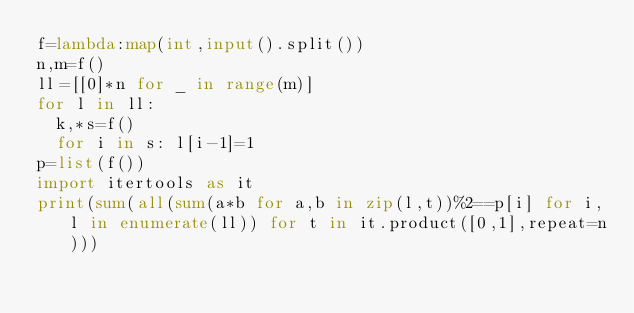<code> <loc_0><loc_0><loc_500><loc_500><_Python_>f=lambda:map(int,input().split())
n,m=f()
ll=[[0]*n for _ in range(m)]
for l in ll:
  k,*s=f()
  for i in s: l[i-1]=1
p=list(f())
import itertools as it
print(sum(all(sum(a*b for a,b in zip(l,t))%2==p[i] for i,l in enumerate(ll)) for t in it.product([0,1],repeat=n)))</code> 